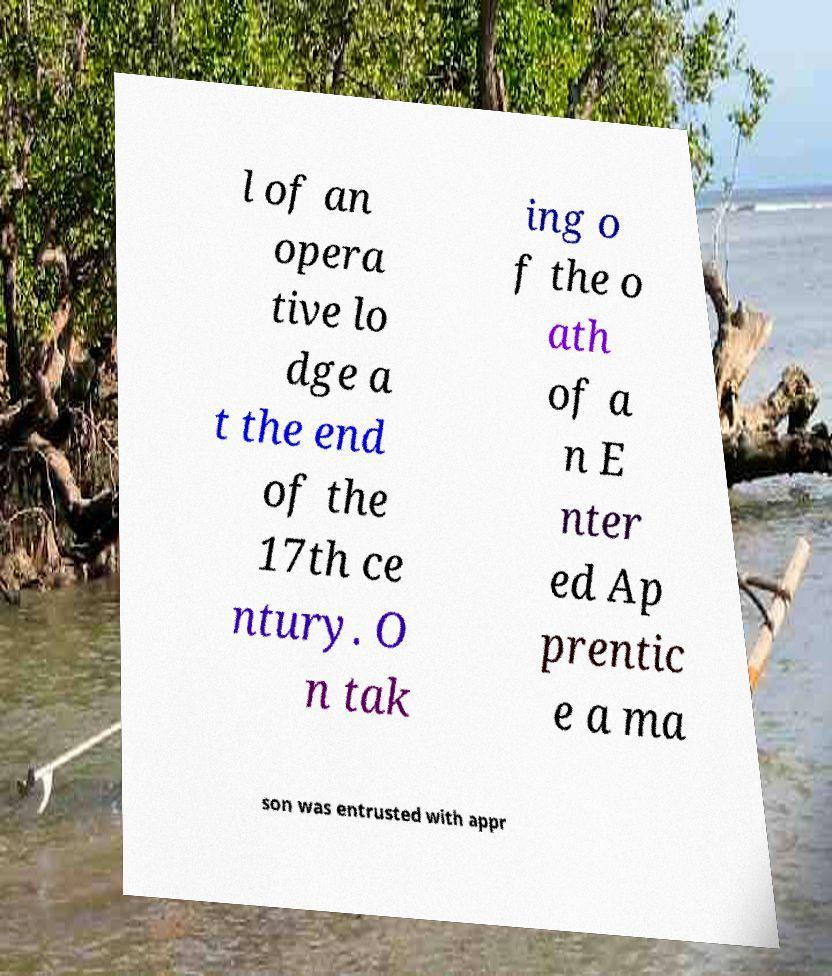Can you read and provide the text displayed in the image?This photo seems to have some interesting text. Can you extract and type it out for me? l of an opera tive lo dge a t the end of the 17th ce ntury. O n tak ing o f the o ath of a n E nter ed Ap prentic e a ma son was entrusted with appr 